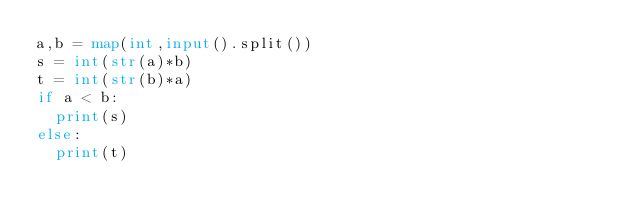<code> <loc_0><loc_0><loc_500><loc_500><_Python_>a,b = map(int,input().split())
s = int(str(a)*b)
t = int(str(b)*a)
if a < b:
  print(s)
else:
  print(t)</code> 